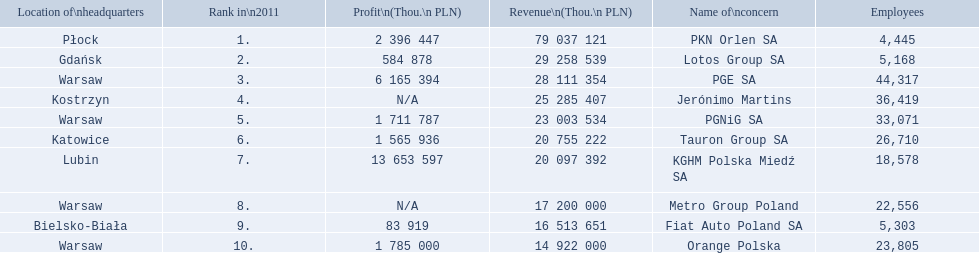What are the names of all the concerns? PKN Orlen SA, Lotos Group SA, PGE SA, Jerónimo Martins, PGNiG SA, Tauron Group SA, KGHM Polska Miedź SA, Metro Group Poland, Fiat Auto Poland SA, Orange Polska. How many employees does pgnig sa have? 33,071. 